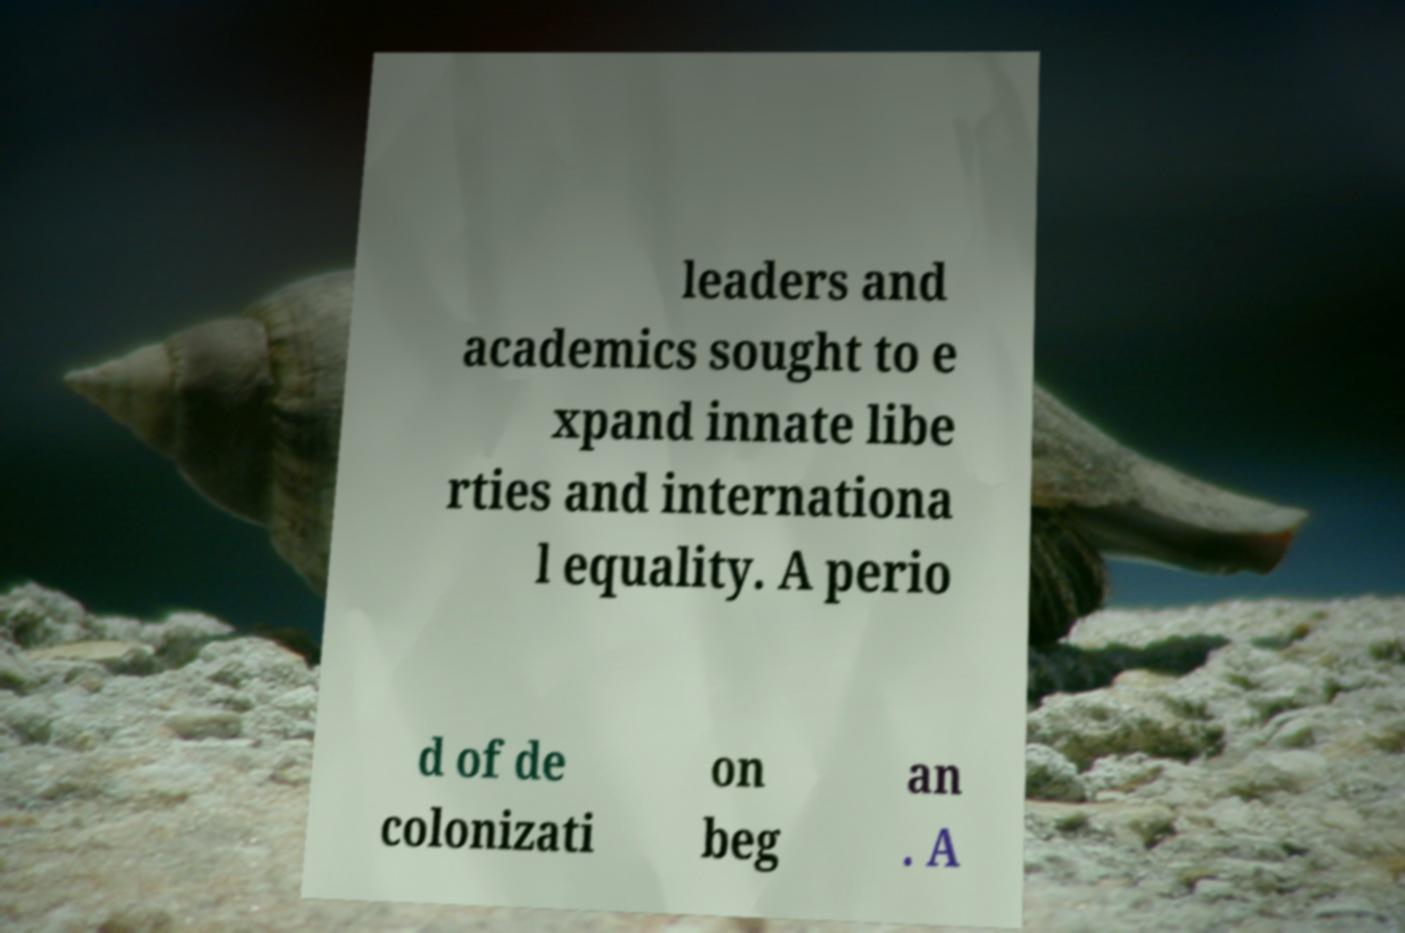Can you accurately transcribe the text from the provided image for me? leaders and academics sought to e xpand innate libe rties and internationa l equality. A perio d of de colonizati on beg an . A 